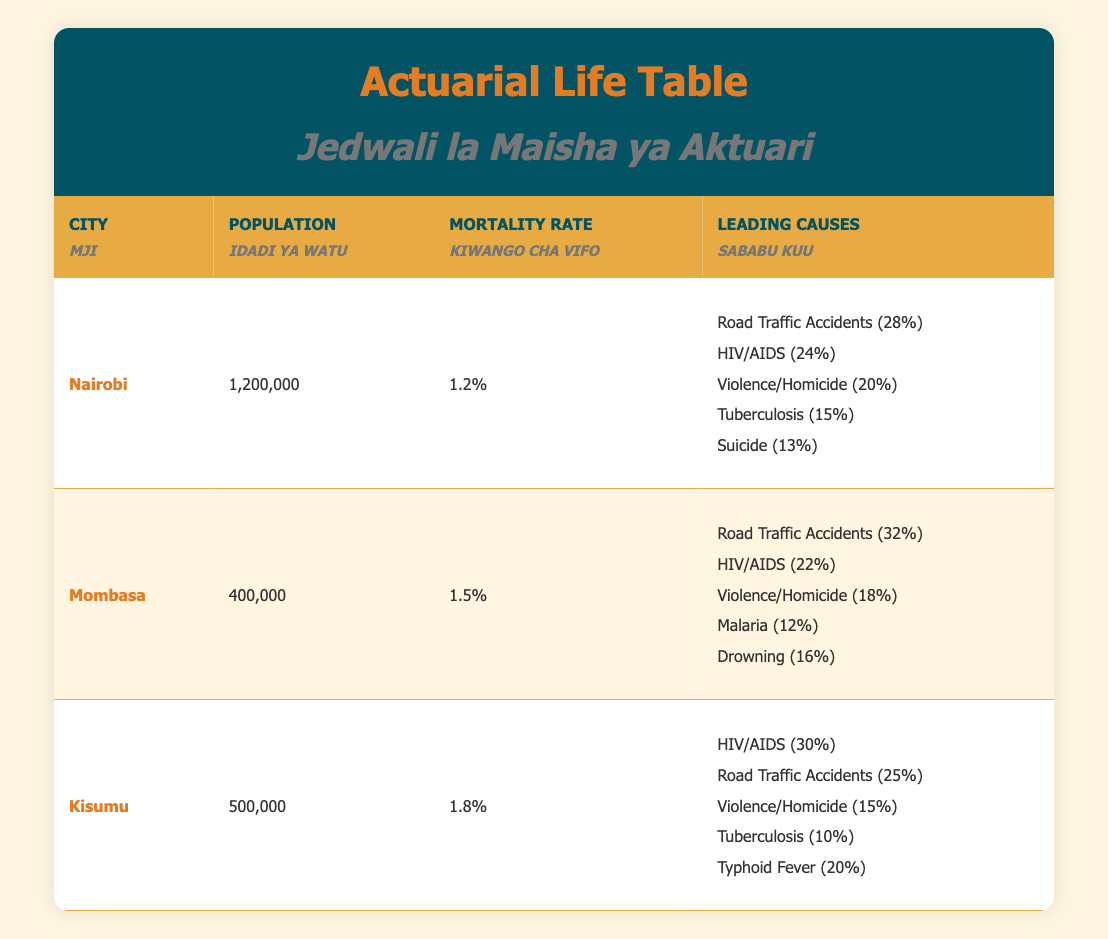What is the population of Nairobi? The table lists the population of Nairobi as 1,200,000.
Answer: 1,200,000 Which city has the highest mortality rate? The mortality rates listed are as follows: Nairobi 1.2%, Mombasa 1.5%, and Kisumu 1.8%. Kisumu has the highest at 1.8%.
Answer: Kisumu What percentage of deaths in Mombasa is due to road traffic accidents? The table indicates that 32% of deaths in Mombasa are caused by road traffic accidents.
Answer: 32% What are the leading causes of death in Nairobi? The leading causes of death in Nairobi, according to the table, are Road Traffic Accidents (28%), HIV/AIDS (24%), Violence/Homicide (20%), Tuberculosis (15%), and Suicide (13%).
Answer: Road Traffic Accidents (28%), HIV/AIDS (24%), Violence/Homicide (20%), Tuberculosis (15%), Suicide (13%) Is the mortality rate in Mombasa higher than in Nairobi? The mortality rate in Mombasa is 1.5% whereas in Nairobi it is 1.2%. This shows that Mombasa has a higher mortality rate.
Answer: Yes What is the total percentage of deaths caused by HIV/AIDS in Kisumu and Nairobi combined? In Kisumu, HIV/AIDS accounts for 30% of deaths, and in Nairobi, it accounts for 24%. Adding these gives 30% + 24% = 54%.
Answer: 54% Which city has a lower mortality rate, Mombasa or Kisumu? Mombasa has a mortality rate of 1.5% while Kisumu has a rate of 1.8%, meaning Mombasa has the lower mortality rate.
Answer: Mombasa What is the average percentage of deaths caused by violence/homicide in the three cities? The percentages for violence/homicide are 20% in Nairobi, 18% in Mombasa, and 15% in Kisumu. The average is (20% + 18% + 15%) / 3 = 17.67%.
Answer: 17.67% Which city has the highest percentage of deaths due to HIV/AIDS? The table shows that Kisumu has 30% of deaths attributed to HIV/AIDS, which is higher than Nairobi (24%) and Mombasa (22%).
Answer: Kisumu 